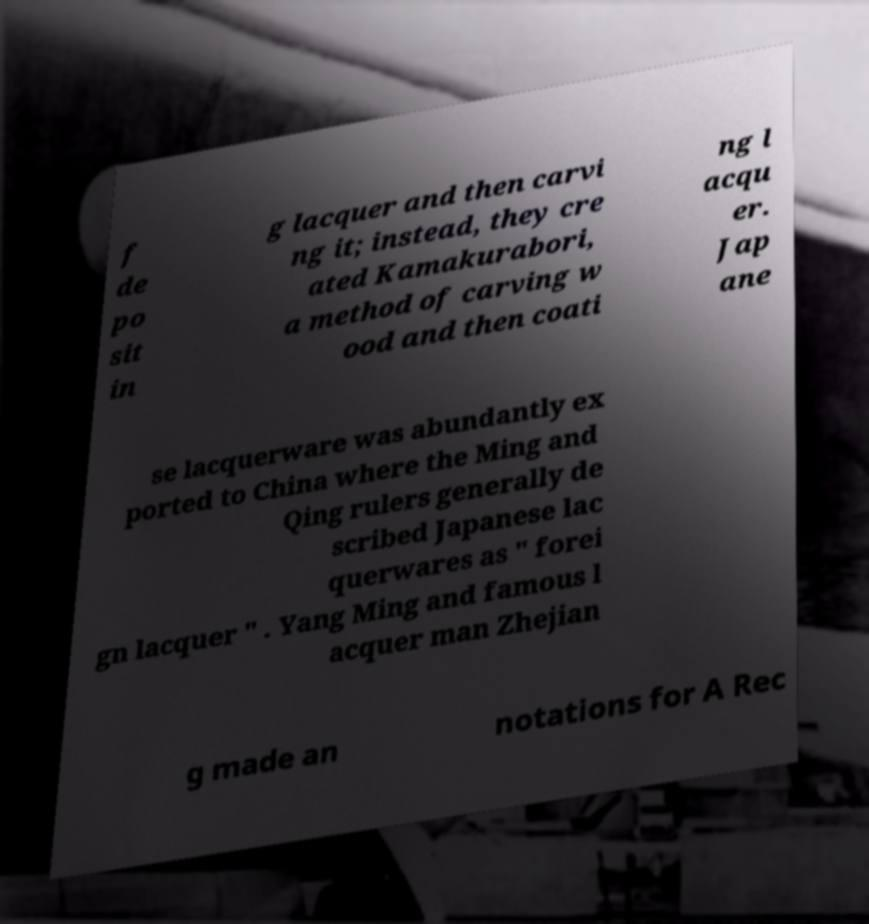Please read and relay the text visible in this image. What does it say? f de po sit in g lacquer and then carvi ng it; instead, they cre ated Kamakurabori, a method of carving w ood and then coati ng l acqu er. Jap ane se lacquerware was abundantly ex ported to China where the Ming and Qing rulers generally de scribed Japanese lac querwares as " forei gn lacquer " . Yang Ming and famous l acquer man Zhejian g made an notations for A Rec 